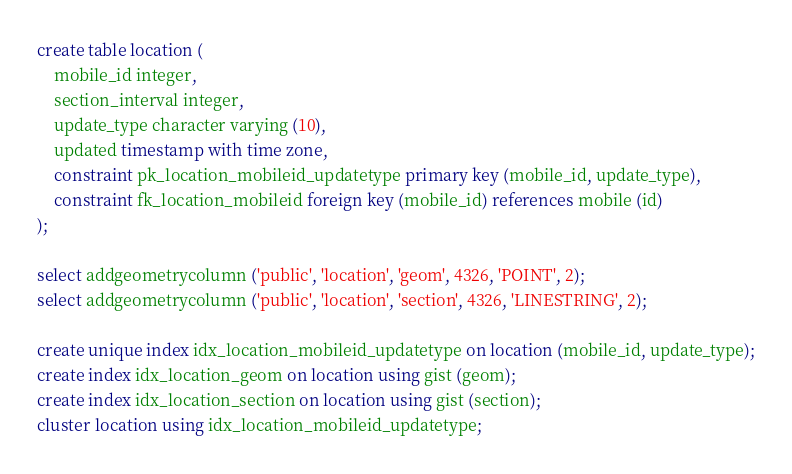<code> <loc_0><loc_0><loc_500><loc_500><_SQL_>create table location (
	mobile_id integer,
	section_interval integer,
	update_type character varying (10),
	updated timestamp with time zone,
	constraint pk_location_mobileid_updatetype primary key (mobile_id, update_type),
	constraint fk_location_mobileid foreign key (mobile_id) references mobile (id)
);

select addgeometrycolumn ('public', 'location', 'geom', 4326, 'POINT', 2);
select addgeometrycolumn ('public', 'location', 'section', 4326, 'LINESTRING', 2);

create unique index idx_location_mobileid_updatetype on location (mobile_id, update_type);
create index idx_location_geom on location using gist (geom);
create index idx_location_section on location using gist (section);
cluster location using idx_location_mobileid_updatetype;</code> 